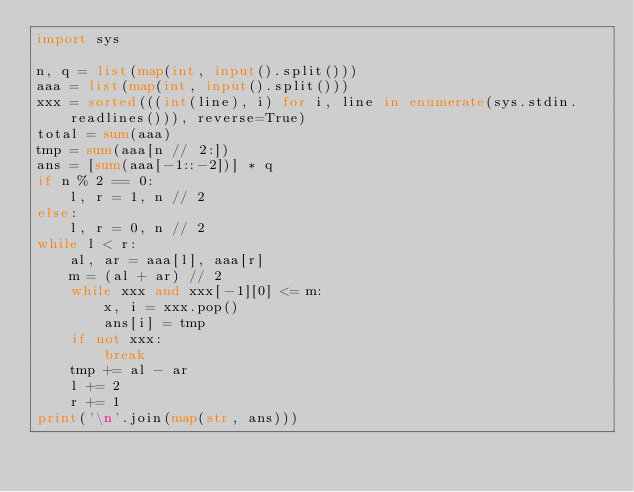Convert code to text. <code><loc_0><loc_0><loc_500><loc_500><_Python_>import sys

n, q = list(map(int, input().split()))
aaa = list(map(int, input().split()))
xxx = sorted(((int(line), i) for i, line in enumerate(sys.stdin.readlines())), reverse=True)
total = sum(aaa)
tmp = sum(aaa[n // 2:])
ans = [sum(aaa[-1::-2])] * q
if n % 2 == 0:
    l, r = 1, n // 2
else:
    l, r = 0, n // 2
while l < r:
    al, ar = aaa[l], aaa[r]
    m = (al + ar) // 2
    while xxx and xxx[-1][0] <= m:
        x, i = xxx.pop()
        ans[i] = tmp
    if not xxx:
        break
    tmp += al - ar
    l += 2
    r += 1
print('\n'.join(map(str, ans)))
</code> 